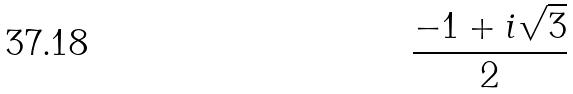<formula> <loc_0><loc_0><loc_500><loc_500>\frac { - 1 + i \sqrt { 3 } } { 2 }</formula> 